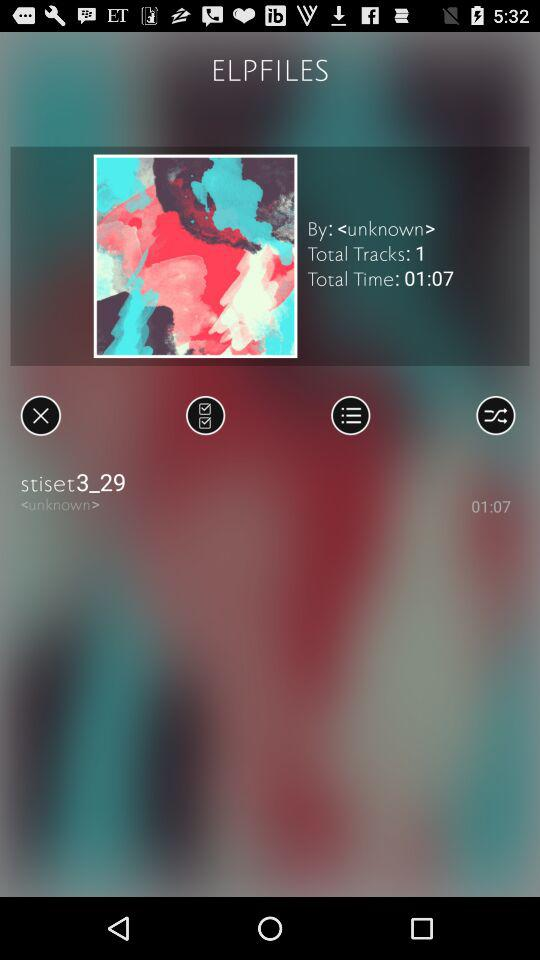What is the total time of the tracks?
Answer the question using a single word or phrase. 01:07 